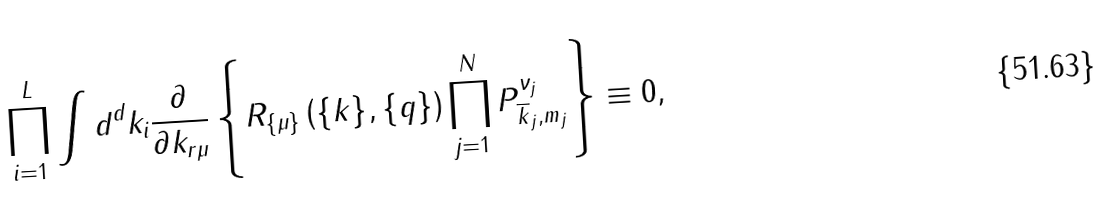Convert formula to latex. <formula><loc_0><loc_0><loc_500><loc_500>\prod _ { i = 1 } ^ { L } \int d ^ { d } k _ { i } \frac { \partial } { \partial k _ { r \mu } } \left \{ R _ { \{ \mu \} } \left ( \{ k \} , \{ q \} \right ) \prod ^ { N } _ { j = 1 } P ^ { \nu _ { j } } _ { \overline { k } _ { j } , m _ { j } } \right \} \equiv 0 ,</formula> 